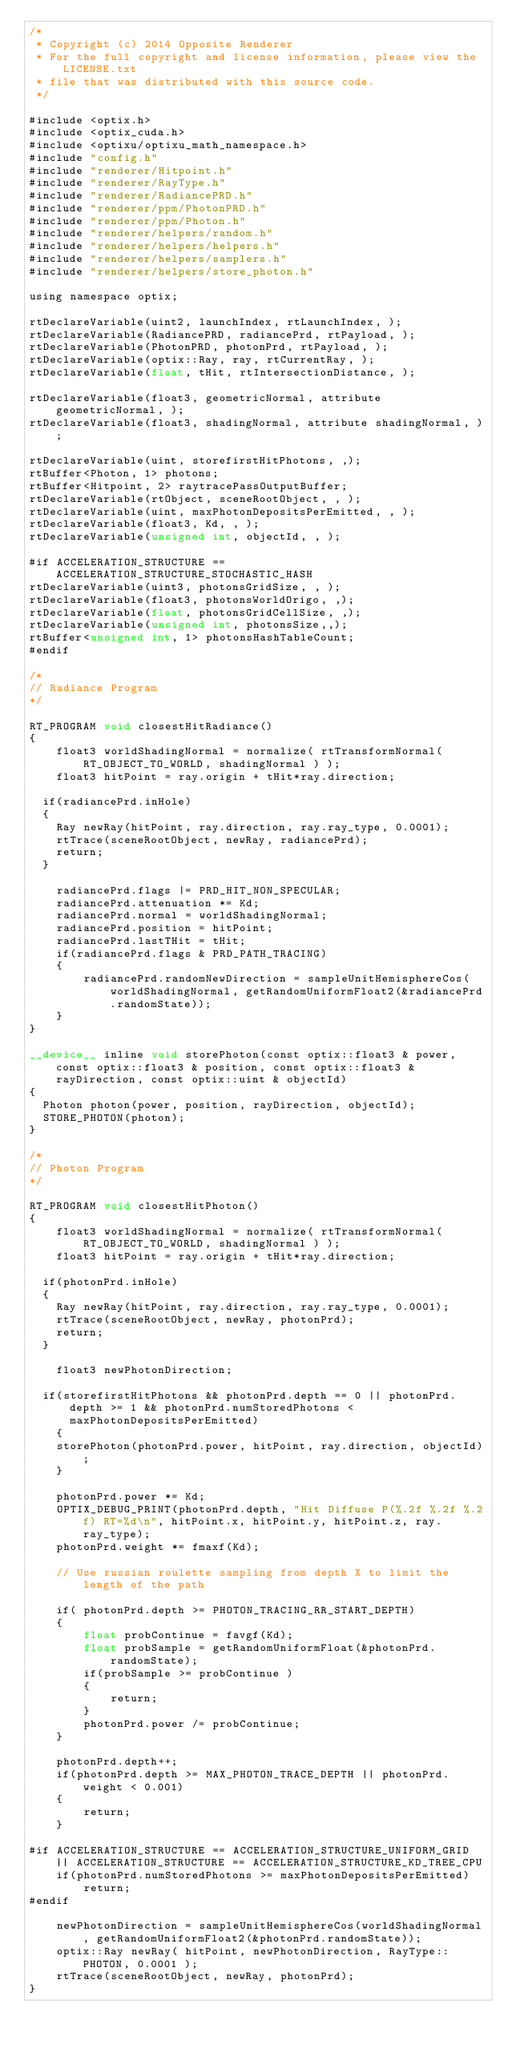<code> <loc_0><loc_0><loc_500><loc_500><_Cuda_>/* 
 * Copyright (c) 2014 Opposite Renderer
 * For the full copyright and license information, please view the LICENSE.txt
 * file that was distributed with this source code.
 */

#include <optix.h>
#include <optix_cuda.h>
#include <optixu/optixu_math_namespace.h>
#include "config.h"
#include "renderer/Hitpoint.h"
#include "renderer/RayType.h"
#include "renderer/RadiancePRD.h"
#include "renderer/ppm/PhotonPRD.h"
#include "renderer/ppm/Photon.h"
#include "renderer/helpers/random.h"
#include "renderer/helpers/helpers.h"
#include "renderer/helpers/samplers.h"
#include "renderer/helpers/store_photon.h"

using namespace optix;

rtDeclareVariable(uint2, launchIndex, rtLaunchIndex, );
rtDeclareVariable(RadiancePRD, radiancePrd, rtPayload, );
rtDeclareVariable(PhotonPRD, photonPrd, rtPayload, );
rtDeclareVariable(optix::Ray, ray, rtCurrentRay, );
rtDeclareVariable(float, tHit, rtIntersectionDistance, );

rtDeclareVariable(float3, geometricNormal, attribute geometricNormal, ); 
rtDeclareVariable(float3, shadingNormal, attribute shadingNormal, ); 

rtDeclareVariable(uint, storefirstHitPhotons, ,);
rtBuffer<Photon, 1> photons;
rtBuffer<Hitpoint, 2> raytracePassOutputBuffer;
rtDeclareVariable(rtObject, sceneRootObject, , );
rtDeclareVariable(uint, maxPhotonDepositsPerEmitted, , );
rtDeclareVariable(float3, Kd, , );
rtDeclareVariable(unsigned int, objectId, , );

#if ACCELERATION_STRUCTURE == ACCELERATION_STRUCTURE_STOCHASTIC_HASH
rtDeclareVariable(uint3, photonsGridSize, , );
rtDeclareVariable(float3, photonsWorldOrigo, ,);
rtDeclareVariable(float, photonsGridCellSize, ,);
rtDeclareVariable(unsigned int, photonsSize,,);
rtBuffer<unsigned int, 1> photonsHashTableCount;
#endif

/*
// Radiance Program
*/

RT_PROGRAM void closestHitRadiance()
{
    float3 worldShadingNormal = normalize( rtTransformNormal( RT_OBJECT_TO_WORLD, shadingNormal ) );
    float3 hitPoint = ray.origin + tHit*ray.direction;

	if(radiancePrd.inHole)
	{
		Ray newRay(hitPoint, ray.direction, ray.ray_type, 0.0001);
		rtTrace(sceneRootObject, newRay, radiancePrd);
		return;
	}

    radiancePrd.flags |= PRD_HIT_NON_SPECULAR;
    radiancePrd.attenuation *= Kd;
    radiancePrd.normal = worldShadingNormal;
    radiancePrd.position = hitPoint;
    radiancePrd.lastTHit = tHit;
    if(radiancePrd.flags & PRD_PATH_TRACING)
    {
        radiancePrd.randomNewDirection = sampleUnitHemisphereCos(worldShadingNormal, getRandomUniformFloat2(&radiancePrd.randomState));
    }
}

__device__ inline void storePhoton(const optix::float3 & power, const optix::float3 & position, const optix::float3 & rayDirection, const optix::uint & objectId)
{
	Photon photon(power, position, rayDirection, objectId);
	STORE_PHOTON(photon);
}

/*
// Photon Program
*/

RT_PROGRAM void closestHitPhoton()
{
    float3 worldShadingNormal = normalize( rtTransformNormal( RT_OBJECT_TO_WORLD, shadingNormal ) );
    float3 hitPoint = ray.origin + tHit*ray.direction;

	if(photonPrd.inHole)
	{
		Ray newRay(hitPoint, ray.direction, ray.ray_type, 0.0001);
		rtTrace(sceneRootObject, newRay, photonPrd);
		return;
	}

    float3 newPhotonDirection;

	if(storefirstHitPhotons && photonPrd.depth == 0 || photonPrd.depth >= 1 && photonPrd.numStoredPhotons < maxPhotonDepositsPerEmitted)
    {
		storePhoton(photonPrd.power, hitPoint, ray.direction, objectId);
    }

    photonPrd.power *= Kd;
    OPTIX_DEBUG_PRINT(photonPrd.depth, "Hit Diffuse P(%.2f %.2f %.2f) RT=%d\n", hitPoint.x, hitPoint.y, hitPoint.z, ray.ray_type);
    photonPrd.weight *= fmaxf(Kd);

    // Use russian roulette sampling from depth X to limit the length of the path

    if( photonPrd.depth >= PHOTON_TRACING_RR_START_DEPTH)
    {
        float probContinue = favgf(Kd);
        float probSample = getRandomUniformFloat(&photonPrd.randomState);
        if(probSample >= probContinue )
        {
            return;
        }
        photonPrd.power /= probContinue;
    }

    photonPrd.depth++;
    if(photonPrd.depth >= MAX_PHOTON_TRACE_DEPTH || photonPrd.weight < 0.001)
    {
        return;
    }

#if ACCELERATION_STRUCTURE == ACCELERATION_STRUCTURE_UNIFORM_GRID || ACCELERATION_STRUCTURE == ACCELERATION_STRUCTURE_KD_TREE_CPU
    if(photonPrd.numStoredPhotons >= maxPhotonDepositsPerEmitted)
        return;
#endif

    newPhotonDirection = sampleUnitHemisphereCos(worldShadingNormal, getRandomUniformFloat2(&photonPrd.randomState));
    optix::Ray newRay( hitPoint, newPhotonDirection, RayType::PHOTON, 0.0001 );
    rtTrace(sceneRootObject, newRay, photonPrd);
}
</code> 